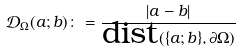Convert formula to latex. <formula><loc_0><loc_0><loc_500><loc_500>\mathcal { D } _ { \Omega } ( a ; b ) \colon = \frac { | a - b | } { \text {dist} ( \{ a ; b \} , \partial \Omega ) }</formula> 